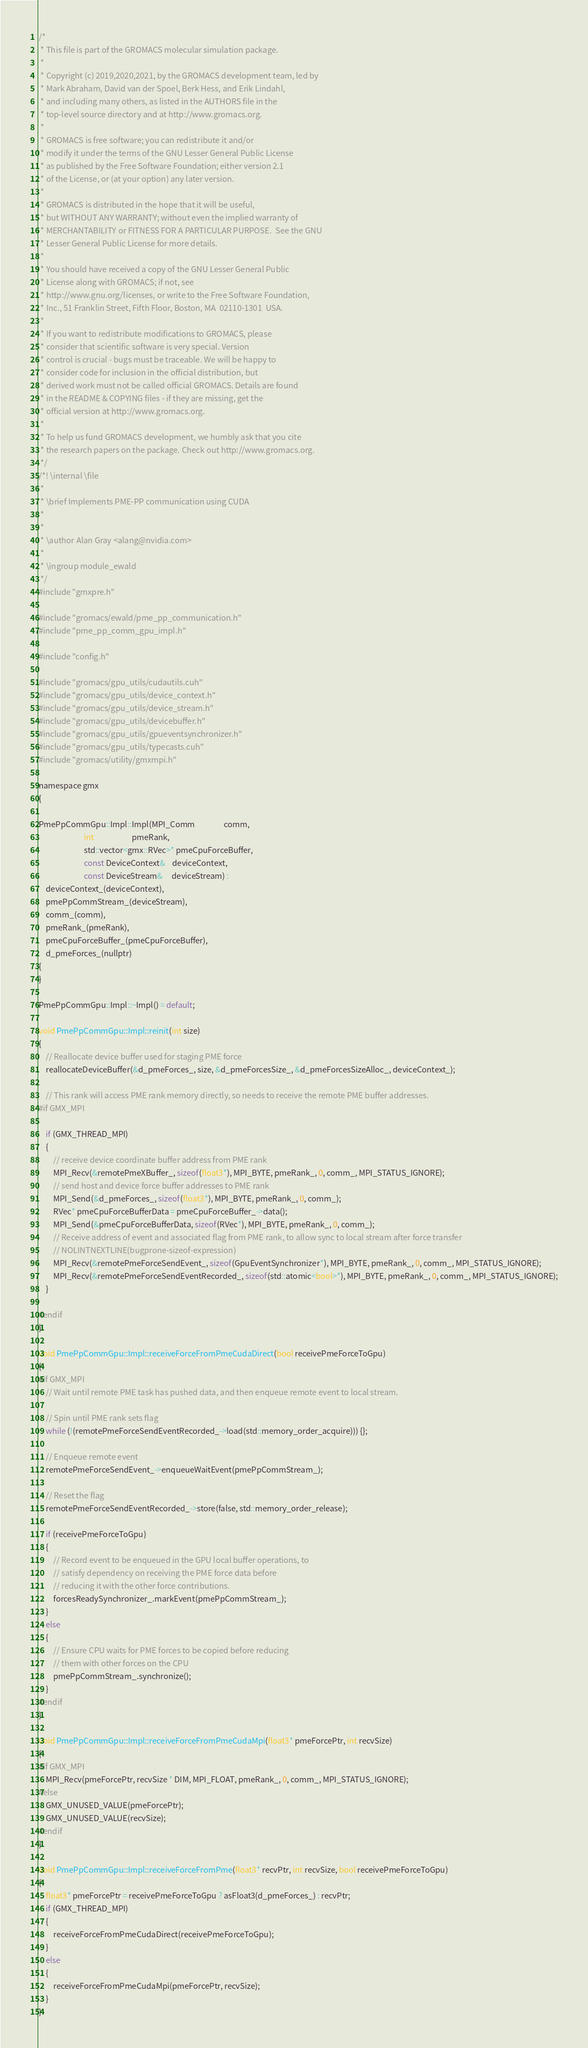Convert code to text. <code><loc_0><loc_0><loc_500><loc_500><_Cuda_>/*
 * This file is part of the GROMACS molecular simulation package.
 *
 * Copyright (c) 2019,2020,2021, by the GROMACS development team, led by
 * Mark Abraham, David van der Spoel, Berk Hess, and Erik Lindahl,
 * and including many others, as listed in the AUTHORS file in the
 * top-level source directory and at http://www.gromacs.org.
 *
 * GROMACS is free software; you can redistribute it and/or
 * modify it under the terms of the GNU Lesser General Public License
 * as published by the Free Software Foundation; either version 2.1
 * of the License, or (at your option) any later version.
 *
 * GROMACS is distributed in the hope that it will be useful,
 * but WITHOUT ANY WARRANTY; without even the implied warranty of
 * MERCHANTABILITY or FITNESS FOR A PARTICULAR PURPOSE.  See the GNU
 * Lesser General Public License for more details.
 *
 * You should have received a copy of the GNU Lesser General Public
 * License along with GROMACS; if not, see
 * http://www.gnu.org/licenses, or write to the Free Software Foundation,
 * Inc., 51 Franklin Street, Fifth Floor, Boston, MA  02110-1301  USA.
 *
 * If you want to redistribute modifications to GROMACS, please
 * consider that scientific software is very special. Version
 * control is crucial - bugs must be traceable. We will be happy to
 * consider code for inclusion in the official distribution, but
 * derived work must not be called official GROMACS. Details are found
 * in the README & COPYING files - if they are missing, get the
 * official version at http://www.gromacs.org.
 *
 * To help us fund GROMACS development, we humbly ask that you cite
 * the research papers on the package. Check out http://www.gromacs.org.
 */
/*! \internal \file
 *
 * \brief Implements PME-PP communication using CUDA
 *
 *
 * \author Alan Gray <alang@nvidia.com>
 *
 * \ingroup module_ewald
 */
#include "gmxpre.h"

#include "gromacs/ewald/pme_pp_communication.h"
#include "pme_pp_comm_gpu_impl.h"

#include "config.h"

#include "gromacs/gpu_utils/cudautils.cuh"
#include "gromacs/gpu_utils/device_context.h"
#include "gromacs/gpu_utils/device_stream.h"
#include "gromacs/gpu_utils/devicebuffer.h"
#include "gromacs/gpu_utils/gpueventsynchronizer.h"
#include "gromacs/gpu_utils/typecasts.cuh"
#include "gromacs/utility/gmxmpi.h"

namespace gmx
{

PmePpCommGpu::Impl::Impl(MPI_Comm                comm,
                         int                     pmeRank,
                         std::vector<gmx::RVec>* pmeCpuForceBuffer,
                         const DeviceContext&    deviceContext,
                         const DeviceStream&     deviceStream) :
    deviceContext_(deviceContext),
    pmePpCommStream_(deviceStream),
    comm_(comm),
    pmeRank_(pmeRank),
    pmeCpuForceBuffer_(pmeCpuForceBuffer),
    d_pmeForces_(nullptr)
{
}

PmePpCommGpu::Impl::~Impl() = default;

void PmePpCommGpu::Impl::reinit(int size)
{
    // Reallocate device buffer used for staging PME force
    reallocateDeviceBuffer(&d_pmeForces_, size, &d_pmeForcesSize_, &d_pmeForcesSizeAlloc_, deviceContext_);

    // This rank will access PME rank memory directly, so needs to receive the remote PME buffer addresses.
#if GMX_MPI

    if (GMX_THREAD_MPI)
    {
        // receive device coordinate buffer address from PME rank
        MPI_Recv(&remotePmeXBuffer_, sizeof(float3*), MPI_BYTE, pmeRank_, 0, comm_, MPI_STATUS_IGNORE);
        // send host and device force buffer addresses to PME rank
        MPI_Send(&d_pmeForces_, sizeof(float3*), MPI_BYTE, pmeRank_, 0, comm_);
        RVec* pmeCpuForceBufferData = pmeCpuForceBuffer_->data();
        MPI_Send(&pmeCpuForceBufferData, sizeof(RVec*), MPI_BYTE, pmeRank_, 0, comm_);
        // Receive address of event and associated flag from PME rank, to allow sync to local stream after force transfer
        // NOLINTNEXTLINE(bugprone-sizeof-expression)
        MPI_Recv(&remotePmeForceSendEvent_, sizeof(GpuEventSynchronizer*), MPI_BYTE, pmeRank_, 0, comm_, MPI_STATUS_IGNORE);
        MPI_Recv(&remotePmeForceSendEventRecorded_, sizeof(std::atomic<bool>*), MPI_BYTE, pmeRank_, 0, comm_, MPI_STATUS_IGNORE);
    }

#endif
}

void PmePpCommGpu::Impl::receiveForceFromPmeCudaDirect(bool receivePmeForceToGpu)
{
#if GMX_MPI
    // Wait until remote PME task has pushed data, and then enqueue remote event to local stream.

    // Spin until PME rank sets flag
    while (!(remotePmeForceSendEventRecorded_->load(std::memory_order_acquire))) {};

    // Enqueue remote event
    remotePmeForceSendEvent_->enqueueWaitEvent(pmePpCommStream_);

    // Reset the flag
    remotePmeForceSendEventRecorded_->store(false, std::memory_order_release);

    if (receivePmeForceToGpu)
    {
        // Record event to be enqueued in the GPU local buffer operations, to
        // satisfy dependency on receiving the PME force data before
        // reducing it with the other force contributions.
        forcesReadySynchronizer_.markEvent(pmePpCommStream_);
    }
    else
    {
        // Ensure CPU waits for PME forces to be copied before reducing
        // them with other forces on the CPU
        pmePpCommStream_.synchronize();
    }
#endif
}

void PmePpCommGpu::Impl::receiveForceFromPmeCudaMpi(float3* pmeForcePtr, int recvSize)
{
#if GMX_MPI
    MPI_Recv(pmeForcePtr, recvSize * DIM, MPI_FLOAT, pmeRank_, 0, comm_, MPI_STATUS_IGNORE);
#else
    GMX_UNUSED_VALUE(pmeForcePtr);
    GMX_UNUSED_VALUE(recvSize);
#endif
}

void PmePpCommGpu::Impl::receiveForceFromPme(float3* recvPtr, int recvSize, bool receivePmeForceToGpu)
{
    float3* pmeForcePtr = receivePmeForceToGpu ? asFloat3(d_pmeForces_) : recvPtr;
    if (GMX_THREAD_MPI)
    {
        receiveForceFromPmeCudaDirect(receivePmeForceToGpu);
    }
    else
    {
        receiveForceFromPmeCudaMpi(pmeForcePtr, recvSize);
    }
}
</code> 